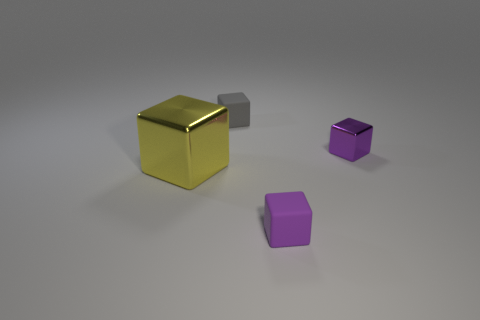There is a small matte object in front of the small metal object; what is its shape?
Provide a short and direct response. Cube. How many blue objects are either large objects or tiny things?
Your response must be concise. 0. There is another tiny thing that is the same material as the gray object; what is its color?
Your answer should be compact. Purple. There is a large shiny block; is it the same color as the small rubber block that is in front of the large block?
Make the answer very short. No. There is a object that is behind the yellow shiny cube and left of the tiny purple shiny object; what is its color?
Offer a terse response. Gray. There is a large yellow metal cube; what number of tiny objects are in front of it?
Offer a terse response. 1. What number of things are purple blocks or cubes left of the tiny gray rubber cube?
Give a very brief answer. 3. There is a small gray rubber thing that is on the right side of the large thing; is there a small gray thing that is on the right side of it?
Provide a short and direct response. No. There is a object in front of the large yellow shiny object; what is its color?
Provide a short and direct response. Purple. Are there an equal number of large metallic objects behind the big shiny object and large metal cubes?
Give a very brief answer. No. 